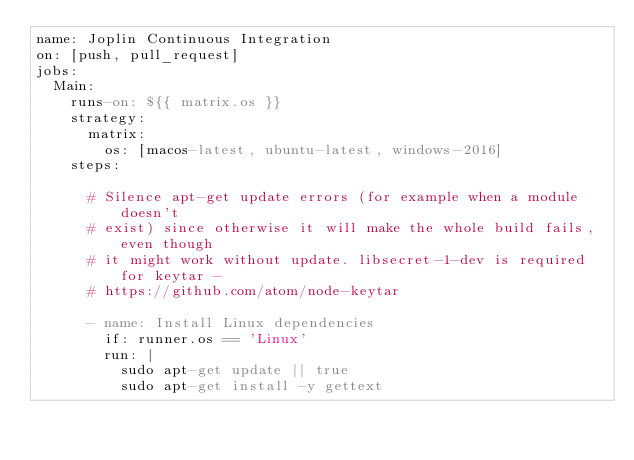Convert code to text. <code><loc_0><loc_0><loc_500><loc_500><_YAML_>name: Joplin Continuous Integration
on: [push, pull_request]
jobs:
  Main:
    runs-on: ${{ matrix.os }}
    strategy:
      matrix:
        os: [macos-latest, ubuntu-latest, windows-2016]
    steps:

      # Silence apt-get update errors (for example when a module doesn't
      # exist) since otherwise it will make the whole build fails, even though
      # it might work without update. libsecret-1-dev is required for keytar -
      # https://github.com/atom/node-keytar

      - name: Install Linux dependencies
        if: runner.os == 'Linux'
        run: |
          sudo apt-get update || true
          sudo apt-get install -y gettext</code> 